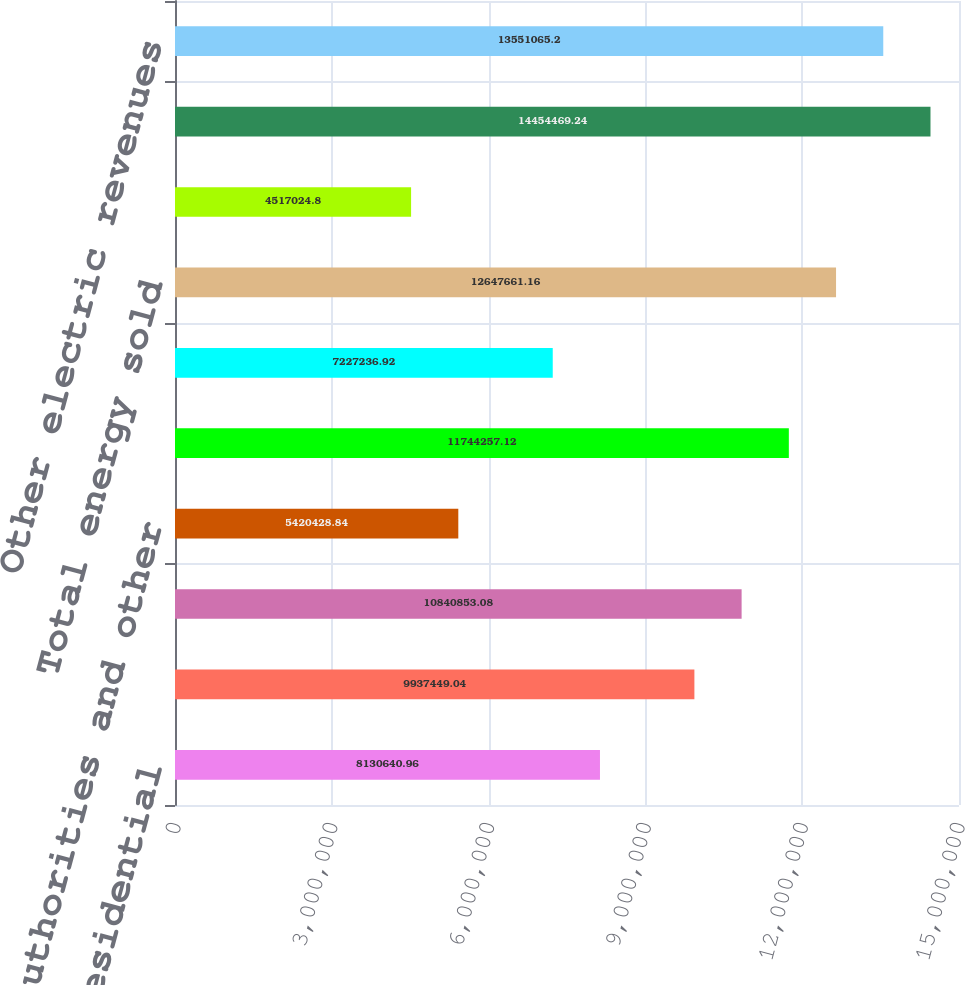Convert chart. <chart><loc_0><loc_0><loc_500><loc_500><bar_chart><fcel>Residential<fcel>Large commercial and<fcel>Small commercial and<fcel>Public authorities and other<fcel>Total retail<fcel>Sales for resale<fcel>Total energy sold<fcel>Wholesale<fcel>Total customers<fcel>Other electric revenues<nl><fcel>8.13064e+06<fcel>9.93745e+06<fcel>1.08409e+07<fcel>5.42043e+06<fcel>1.17443e+07<fcel>7.22724e+06<fcel>1.26477e+07<fcel>4.51702e+06<fcel>1.44545e+07<fcel>1.35511e+07<nl></chart> 